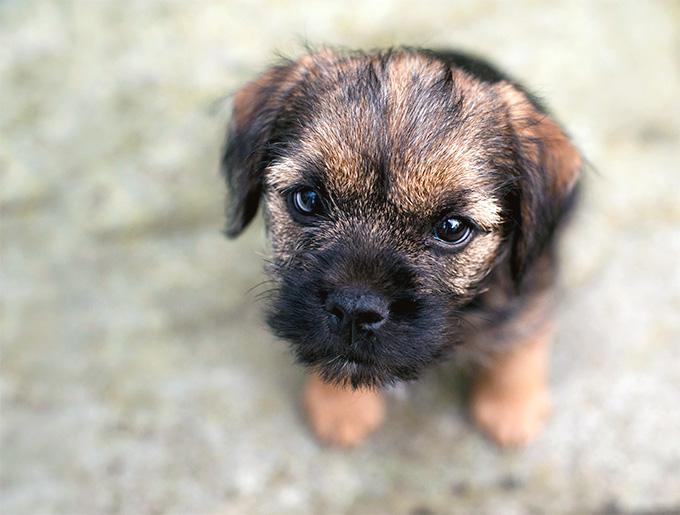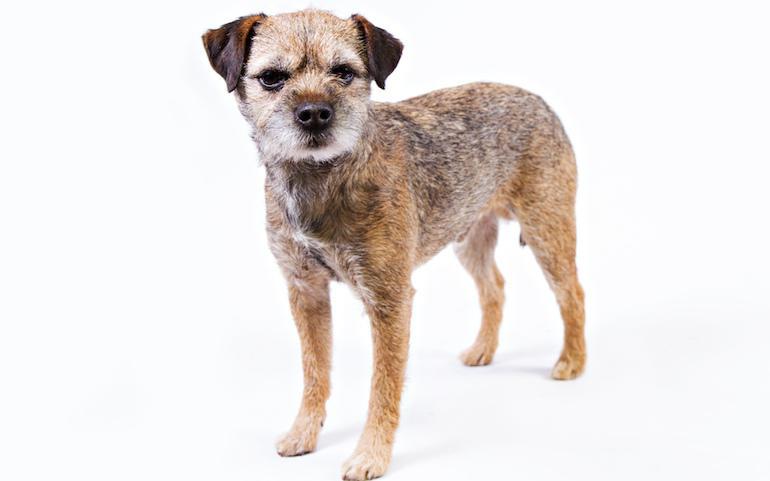The first image is the image on the left, the second image is the image on the right. For the images shown, is this caption "On the right, the dog's body is turned to the left." true? Answer yes or no. Yes. The first image is the image on the left, the second image is the image on the right. Examine the images to the left and right. Is the description "there is no visible grass" accurate? Answer yes or no. Yes. 